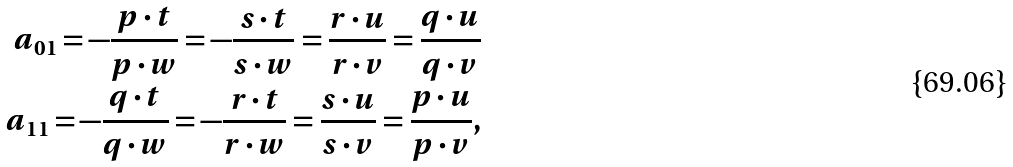<formula> <loc_0><loc_0><loc_500><loc_500>a _ { 0 1 } = - \frac { p \cdot t } { p \cdot w } = - \frac { s \cdot t } { s \cdot w } = \frac { r \cdot u } { r \cdot v } = \frac { q \cdot u } { q \cdot v } \\ a _ { 1 1 } = - \frac { q \cdot t } { q \cdot w } = - \frac { r \cdot t } { r \cdot w } = \frac { s \cdot u } { s \cdot v } = \frac { p \cdot u } { p \cdot v } ,</formula> 